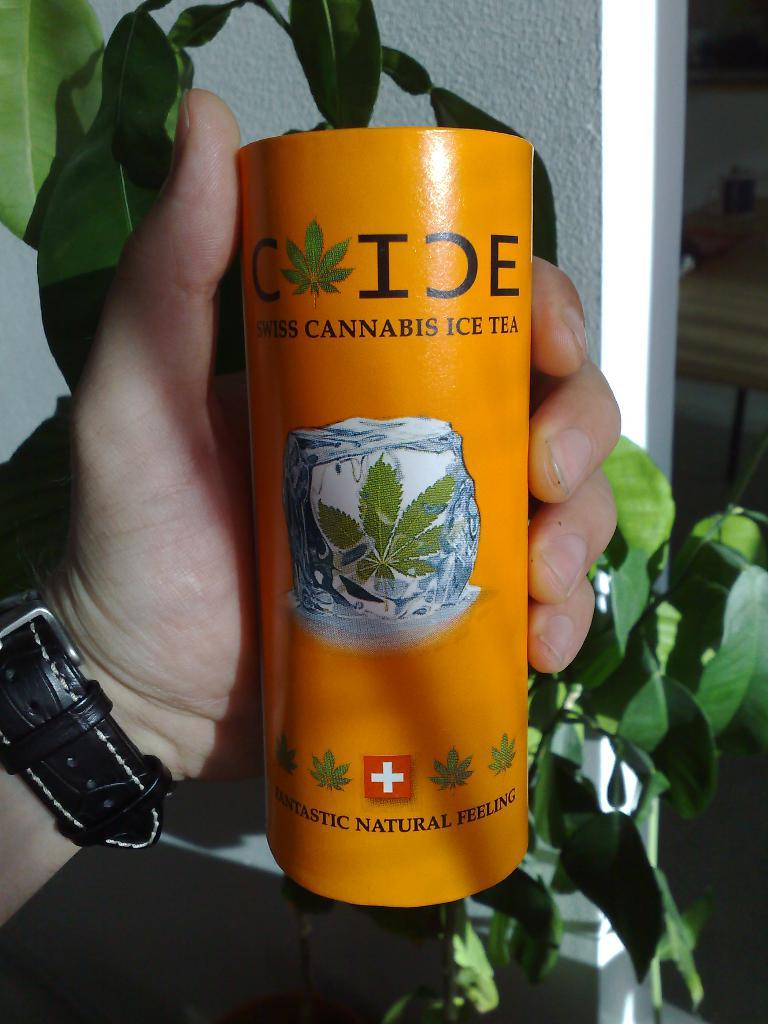Who or what is present in the image? There is a person in the image. What is the person holding in the image? The person is holding a tin in the image. What can be seen on the tin? There is text on the tin. What can be seen in the background of the image? There is a wall and a plant in the background of the image. What accessory is the person wearing? The person is wearing a wristwatch. What type of bat can be seen flying in the image? There is no bat present in the image; it features a person holding a tin with text on it, and a wall and plant in the background. 